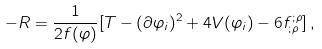<formula> <loc_0><loc_0><loc_500><loc_500>- R = \frac { 1 } { 2 f ( \varphi ) } [ T - ( \partial \varphi _ { i } ) ^ { 2 } + 4 V ( \varphi _ { i } ) - 6 f ^ { ; \rho } _ { ; \rho } ] \, , \,</formula> 